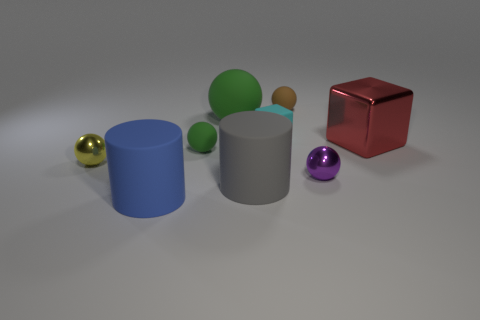Are there any other tiny purple objects of the same shape as the tiny purple metallic thing?
Provide a succinct answer. No. There is a blue matte object; is it the same shape as the big gray rubber object on the right side of the small green thing?
Make the answer very short. Yes. What number of balls are either small gray matte things or large green objects?
Offer a very short reply. 1. What shape is the large rubber thing in front of the large gray thing?
Provide a succinct answer. Cylinder. How many tiny things have the same material as the big red block?
Keep it short and to the point. 2. Is the number of gray rubber cylinders that are in front of the big gray cylinder less than the number of large blue shiny things?
Your response must be concise. No. What is the size of the rubber ball that is in front of the green sphere behind the red metallic cube?
Offer a very short reply. Small. There is a matte block; is its color the same as the tiny metallic object that is right of the brown matte object?
Provide a short and direct response. No. There is a brown thing that is the same size as the yellow metallic object; what is its material?
Your answer should be compact. Rubber. Is the number of metallic balls that are to the right of the small green object less than the number of tiny purple metallic objects that are to the left of the big green matte object?
Keep it short and to the point. No. 